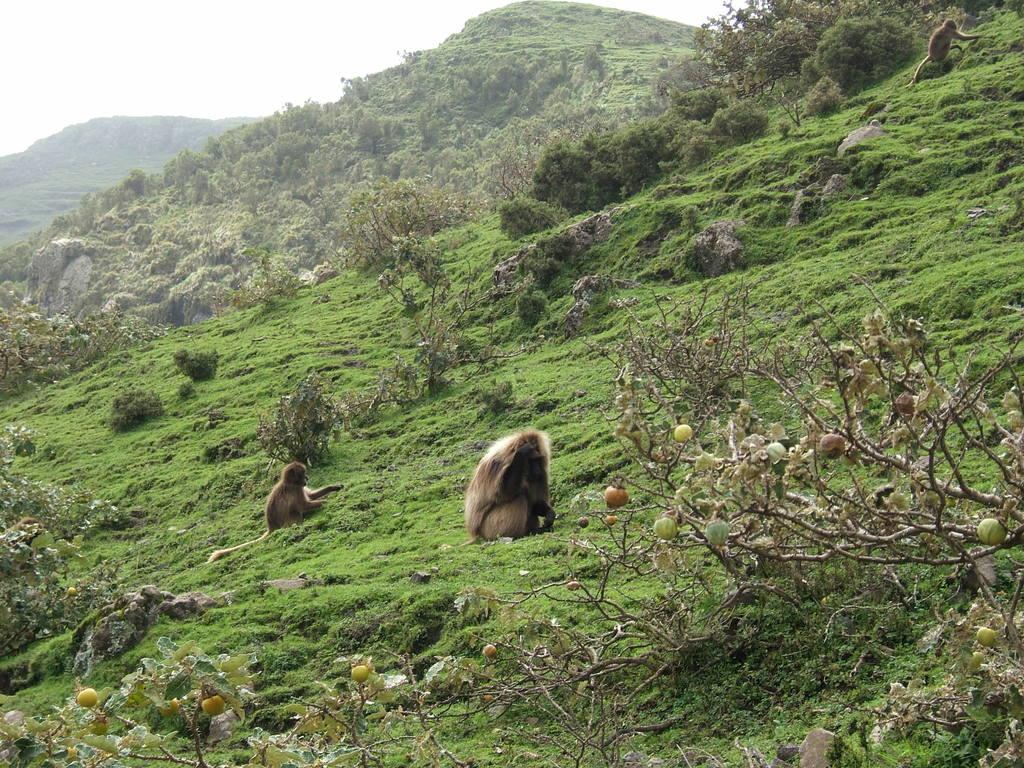What can be seen on the ground in the image? There are two animals on the ground in the image. What is on the tree in the image? There are fruits on a tree in the image. What is visible in the background of the image? There are many trees and mountains in the background of the image. What is the color of the sky in the image? The sky is white in the image. What type of music can be heard coming from the stove in the image? There is no stove present in the image, and therefore no music can be heard from it. Is there an oven visible in the image? No, there is no oven present in the image. 